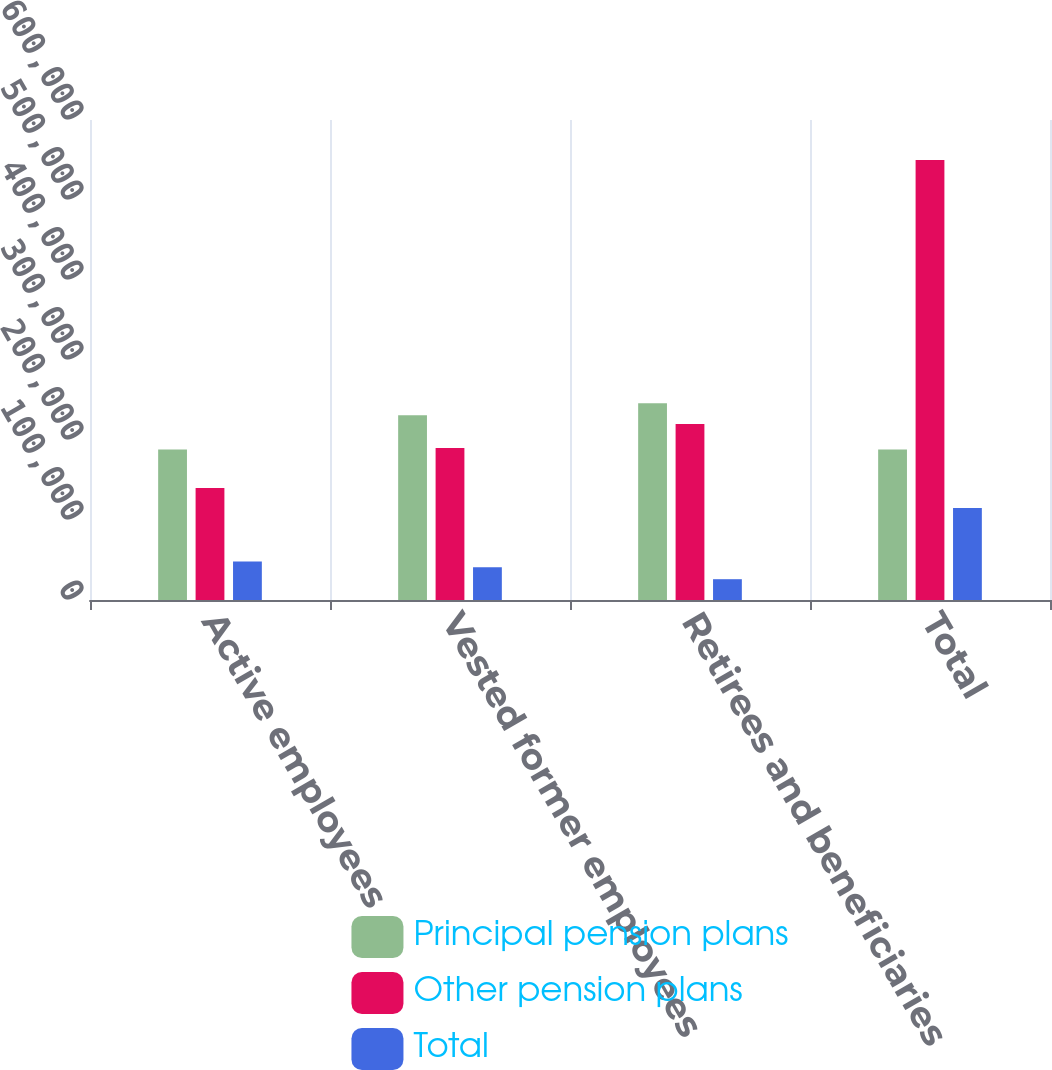Convert chart. <chart><loc_0><loc_0><loc_500><loc_500><stacked_bar_chart><ecel><fcel>Active employees<fcel>Vested former employees<fcel>Retirees and beneficiaries<fcel>Total<nl><fcel>Principal pension plans<fcel>188000<fcel>231000<fcel>246000<fcel>188000<nl><fcel>Other pension plans<fcel>140000<fcel>190000<fcel>220000<fcel>550000<nl><fcel>Total<fcel>48000<fcel>41000<fcel>26000<fcel>115000<nl></chart> 